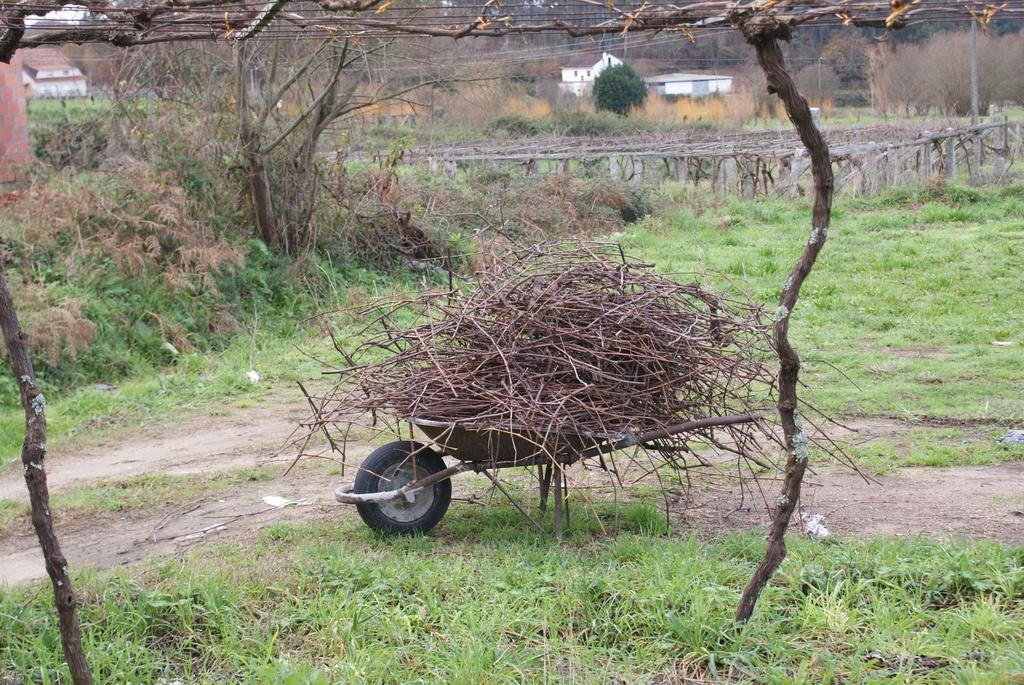What is on the wheelbarrow in the image? There are stems on a wheelbarrow in the image. What type of living organisms can be seen in the image? Plants, grass, and trees are visible in the image. What type of structures are present in the image? There are houses in the image. How many cacti can be seen in the image? There are no cacti present in the image. What plot of land is being cultivated in the image? The image does not show a specific plot of land being cultivated; it simply depicts a wheelbarrow with stems, plants, grass, houses, and trees. 